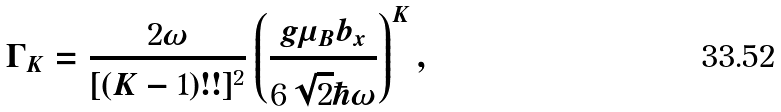Convert formula to latex. <formula><loc_0><loc_0><loc_500><loc_500>\Gamma _ { K } = \frac { 2 \omega } { [ ( K - 1 ) ! ! ] ^ { 2 } } \left ( \frac { g \mu _ { B } b _ { x } } { 6 \sqrt { 2 } \hbar { \omega } } \right ) ^ { K } ,</formula> 